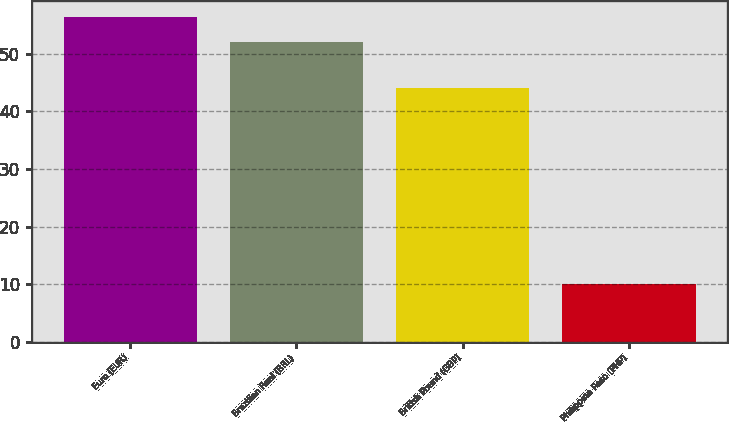Convert chart to OTSL. <chart><loc_0><loc_0><loc_500><loc_500><bar_chart><fcel>Euro (EUR)<fcel>Brazilian Real (BRL)<fcel>British Pound (GBP)<fcel>Philippine Peso (PHP)<nl><fcel>56.4<fcel>52<fcel>44<fcel>10<nl></chart> 